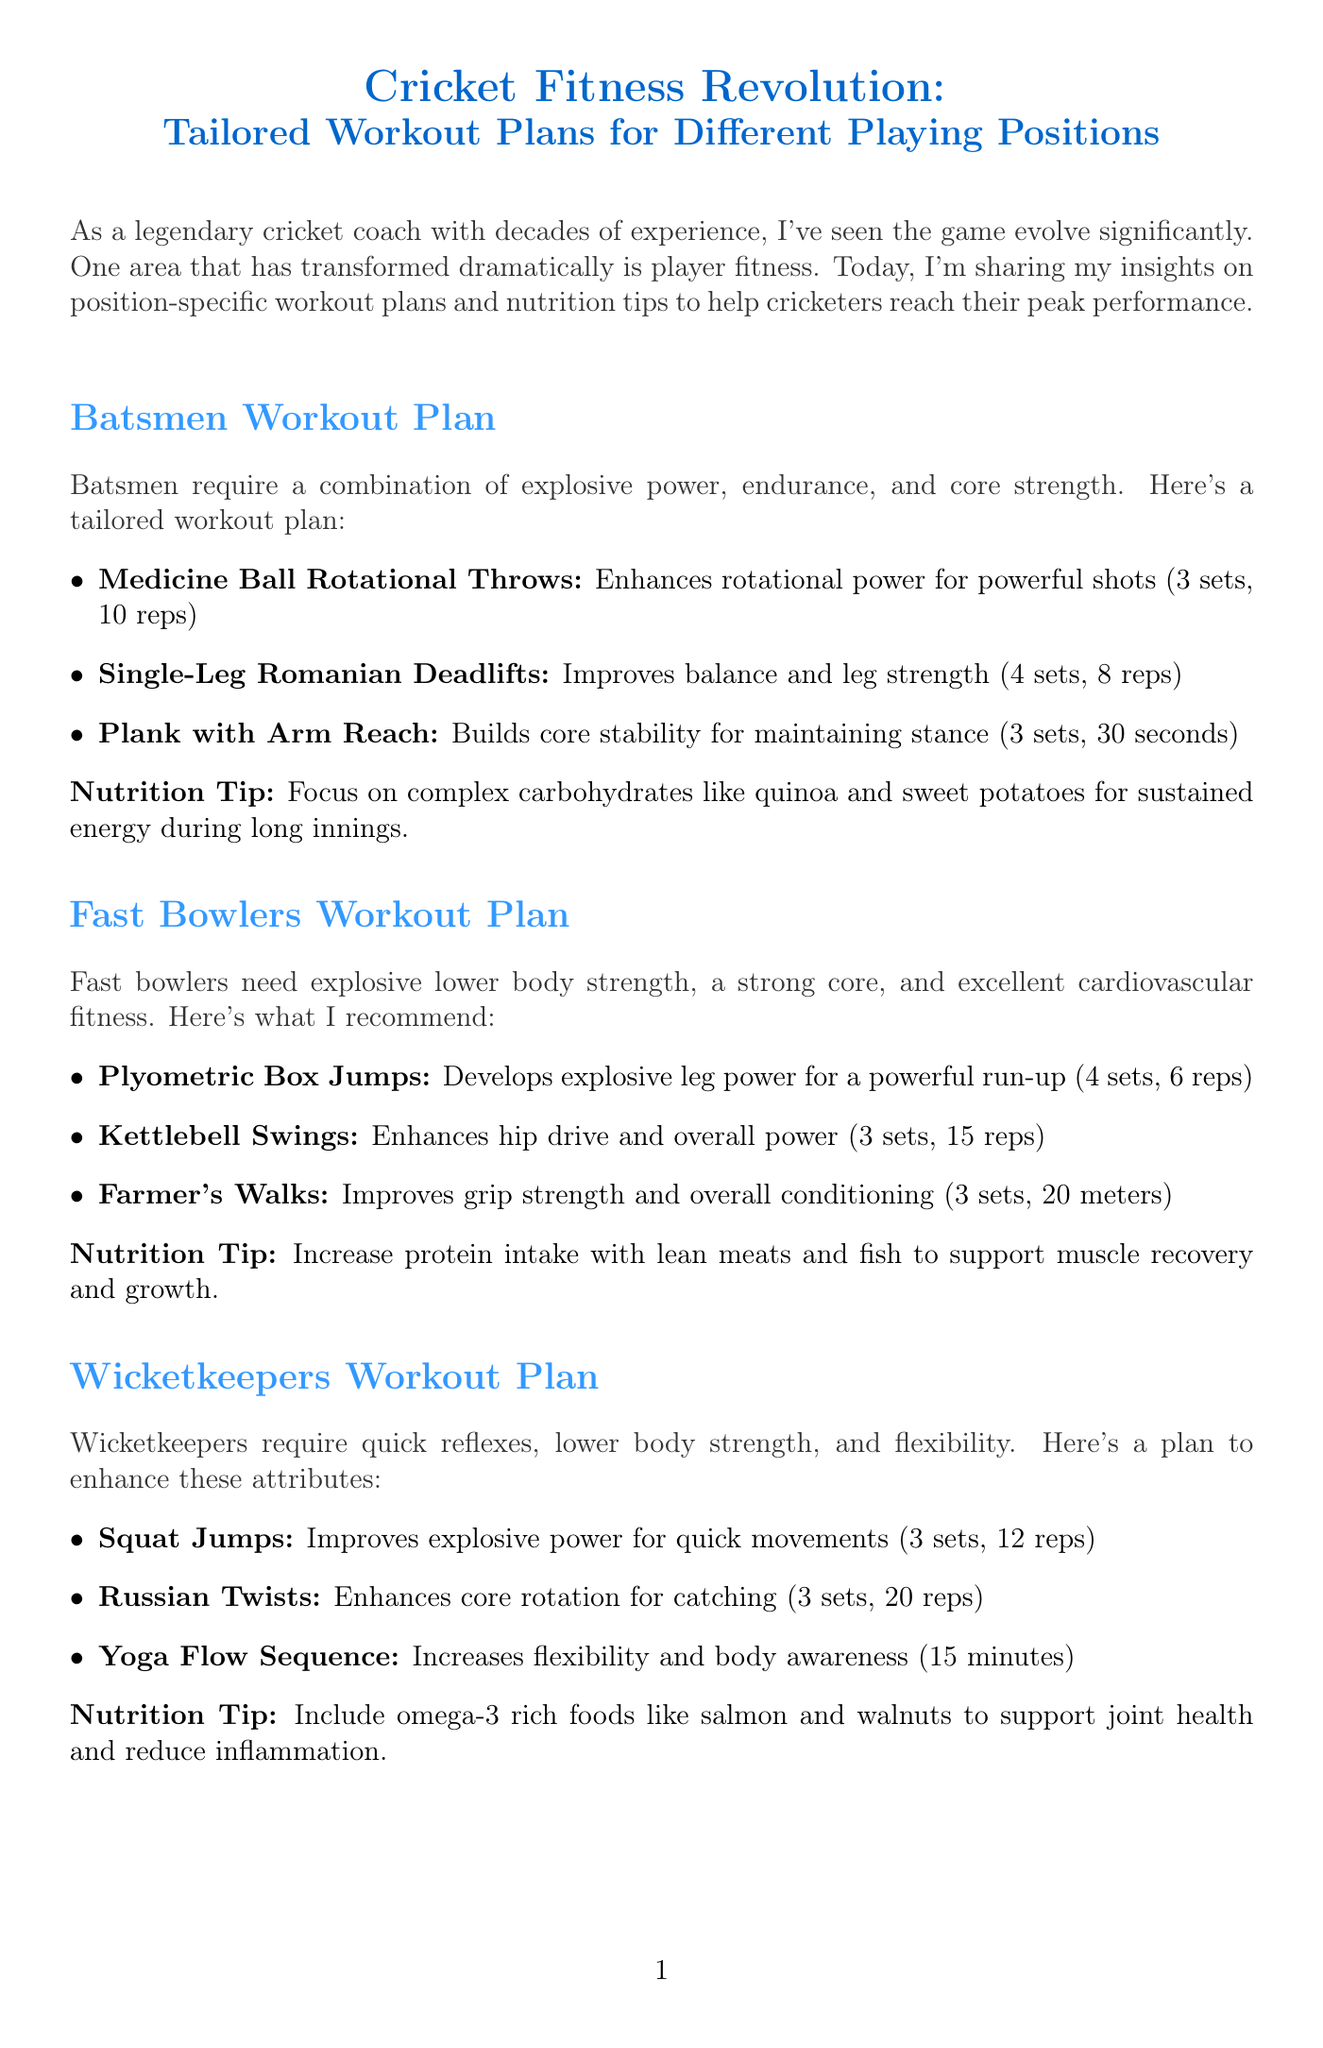What is the newsletter title? The title is stated prominently at the beginning of the document.
Answer: Cricket Fitness Revolution: Tailored Workout Plans for Different Playing Positions How many exercises are recommended for fast bowlers? The document lists the number of exercises in the fast bowlers workout plan.
Answer: 3 What is the nutrition tip for batsmen? Each position’s section provides a specific nutrition tip.
Answer: Focus on complex carbohydrates like quinoa and sweet potatoes for sustained energy during long innings What exercise is recommended to improve flexibility for wicketkeepers? The exercises specified for wicketkeepers include one aimed at enhancing flexibility.
Answer: Yoga Flow Sequence What should spin bowlers consume to maintain bone health? The nutrition tip section for spin bowlers provides insight into dietary recommendations.
Answer: Foods rich in vitamin D and calcium, like fortified milk and yogurt 